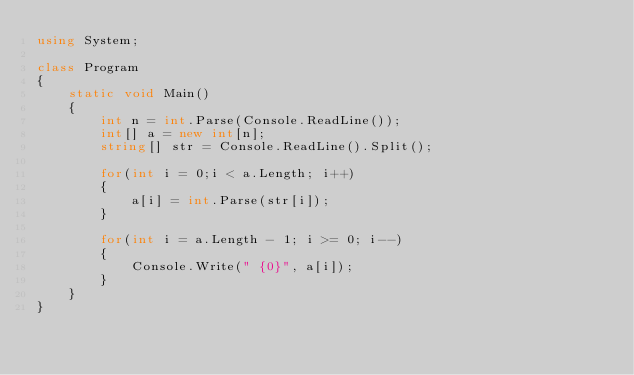<code> <loc_0><loc_0><loc_500><loc_500><_C#_>using System;

class Program
{
    static void Main()
    {
        int n = int.Parse(Console.ReadLine());
        int[] a = new int[n];
        string[] str = Console.ReadLine().Split();

        for(int i = 0;i < a.Length; i++)
        {
            a[i] = int.Parse(str[i]);
        }

        for(int i = a.Length - 1; i >= 0; i--)
        {
            Console.Write(" {0}", a[i]);
        }
    }
}</code> 